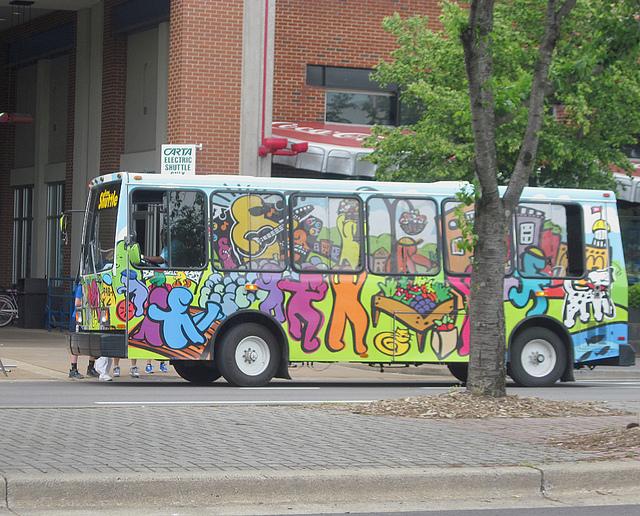Is this a school bus?
Give a very brief answer. No. What kind of dog is painted on the bus?
Keep it brief. Dalmatian. Is the artwork on the bus vandalism?
Quick response, please. No. 